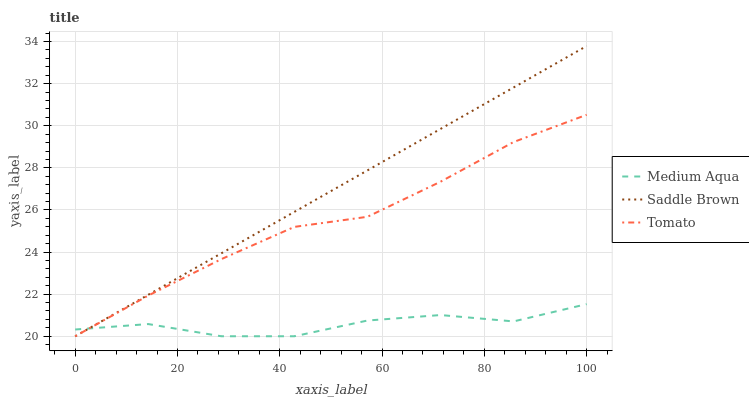Does Medium Aqua have the minimum area under the curve?
Answer yes or no. Yes. Does Saddle Brown have the maximum area under the curve?
Answer yes or no. Yes. Does Saddle Brown have the minimum area under the curve?
Answer yes or no. No. Does Medium Aqua have the maximum area under the curve?
Answer yes or no. No. Is Saddle Brown the smoothest?
Answer yes or no. Yes. Is Medium Aqua the roughest?
Answer yes or no. Yes. Is Medium Aqua the smoothest?
Answer yes or no. No. Is Saddle Brown the roughest?
Answer yes or no. No. Does Tomato have the lowest value?
Answer yes or no. Yes. Does Saddle Brown have the highest value?
Answer yes or no. Yes. Does Medium Aqua have the highest value?
Answer yes or no. No. Does Medium Aqua intersect Tomato?
Answer yes or no. Yes. Is Medium Aqua less than Tomato?
Answer yes or no. No. Is Medium Aqua greater than Tomato?
Answer yes or no. No. 